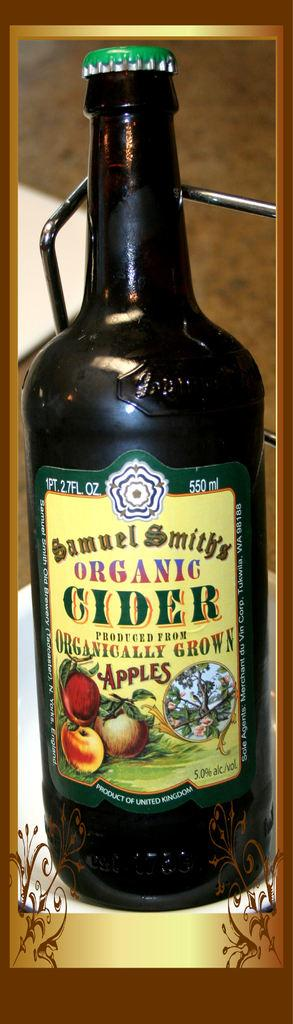<image>
Relay a brief, clear account of the picture shown. The bottle of Samuel Smith's Organ Cider has a green bottle cap on it. 